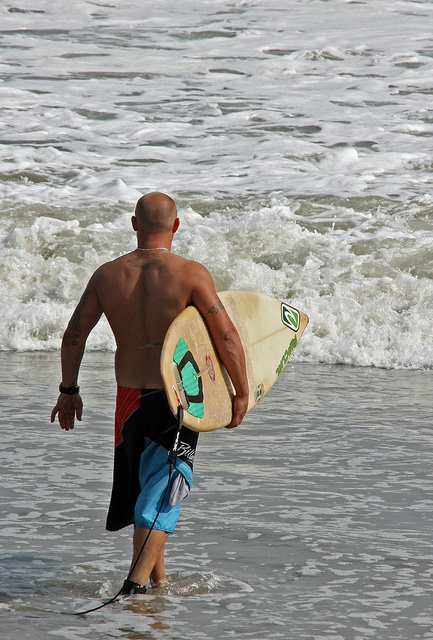Describe the objects in this image and their specific colors. I can see people in darkgray, black, maroon, and brown tones and surfboard in darkgray and tan tones in this image. 